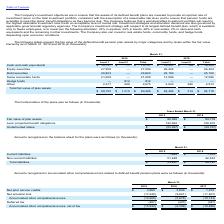Looking at Logitech International Sa's financial data, please calculate: What is the increase in the fair value of plan assets from 2018 to 2019? Based on the calculation: $90,365 - $84,718, the result is 5647 (in thousands). This is based on the information: "$ 89,155 $ 1,210 $ 90,365 $ 84,404 $ 314 $ 84,718 $ 89,155 $ 1,210 $ 90,365 $ 84,404 $ 314 $ 84,718..." The key data points involved are: 84,718, 90,365. Also, can you calculate: What is the percentage increase of projected benefit obligations in 2019 compared to 2018? To answer this question, I need to perform calculations using the financial data. The calculation is: ($143,662 - $128,915) / $128,915, which equals 11.44 (percentage). This is based on the information: "Less: projected benefit obligations 143,662 128,915 Less: projected benefit obligations 143,662 128,915..." The key data points involved are: 128,915, 143,662. Also, What was the fair value of plan assets in 2018? According to the financial document, $84,718 (in thousands). The relevant text states: "$ 89,155 $ 1,210 $ 90,365 $ 84,404 $ 314 $ 84,718..." Also, What is the amount of underfunded status in 2019? According to the financial document, $(53,297) (in thousands). The relevant text states: "Underfunded status $ (53,297) $ (44,197)..." Also, can you calculate: What is the average of Underfunded status between 2018 and 2019? To answer this question, I need to perform calculations using the financial data. The calculation is: ($(53,297) + $(44,197)) / 2, which equals -48747 (in thousands). This is based on the information: "Underfunded status $ (53,297) $ (44,197) Underfunded status $ (53,297) $ (44,197) Underfunded status $ (53,297) $ (44,197)..." The key data points involved are: 2, 44,197, 53,297. Also, What is the funded status of 2018? According to the financial document, $(44,197) (in thousands). The relevant text states: "Underfunded status $ (53,297) $ (44,197)..." 